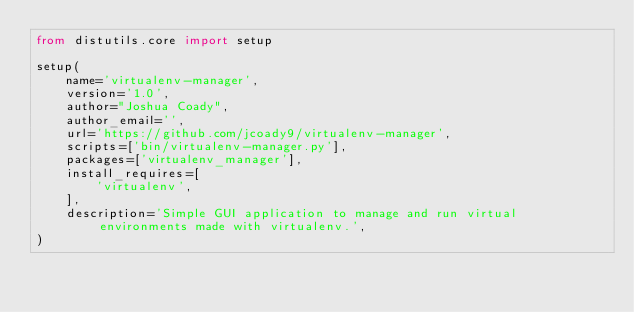<code> <loc_0><loc_0><loc_500><loc_500><_Python_>from distutils.core import setup

setup(
    name='virtualenv-manager',
    version='1.0',
    author="Joshua Coady",
    author_email='',
    url='https://github.com/jcoady9/virtualenv-manager',
    scripts=['bin/virtualenv-manager.py'],
    packages=['virtualenv_manager'],
    install_requires=[
        'virtualenv',
    ],
    description='Simple GUI application to manage and run virtual environments made with virtualenv.',
)
</code> 